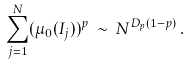<formula> <loc_0><loc_0><loc_500><loc_500>\sum _ { j = 1 } ^ { N } ( \mu _ { 0 } ( I _ { j } ) ) ^ { p } \, \sim \, N ^ { D _ { p } ( 1 - p ) } \, .</formula> 